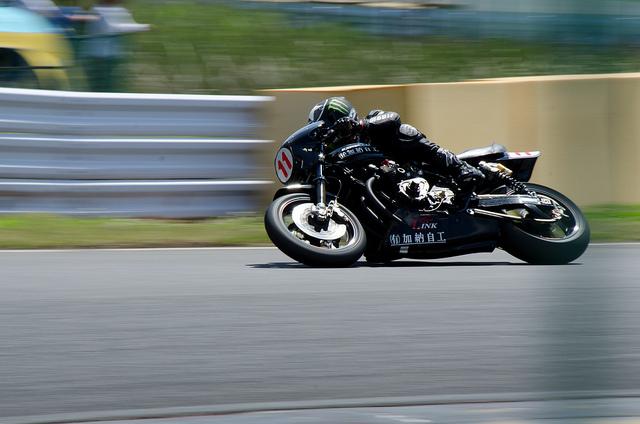What is on the man's head?
Be succinct. Helmet. What position is the bike in?
Concise answer only. Sideways. Is the bike parked in front of a building?
Give a very brief answer. No. Is the bike black?
Give a very brief answer. Yes. 